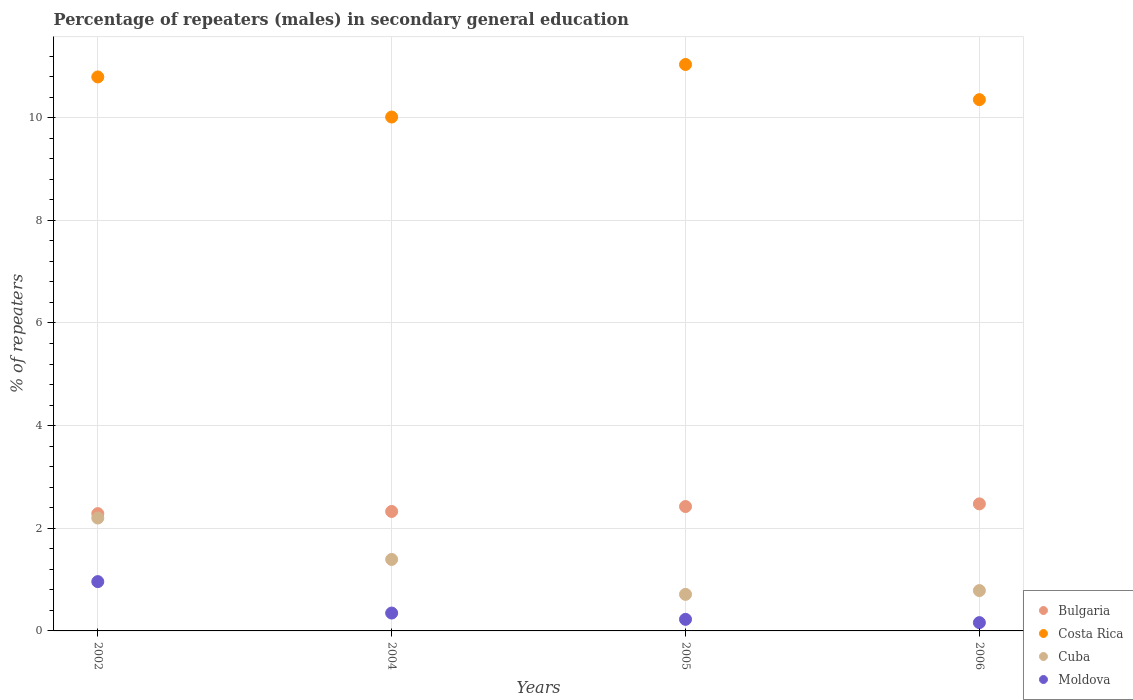What is the percentage of male repeaters in Costa Rica in 2004?
Offer a terse response. 10.01. Across all years, what is the maximum percentage of male repeaters in Bulgaria?
Make the answer very short. 2.48. Across all years, what is the minimum percentage of male repeaters in Costa Rica?
Ensure brevity in your answer.  10.01. What is the total percentage of male repeaters in Cuba in the graph?
Your answer should be compact. 5.09. What is the difference between the percentage of male repeaters in Moldova in 2002 and that in 2005?
Make the answer very short. 0.73. What is the difference between the percentage of male repeaters in Bulgaria in 2002 and the percentage of male repeaters in Moldova in 2005?
Your response must be concise. 2.06. What is the average percentage of male repeaters in Cuba per year?
Provide a succinct answer. 1.27. In the year 2002, what is the difference between the percentage of male repeaters in Bulgaria and percentage of male repeaters in Cuba?
Give a very brief answer. 0.09. In how many years, is the percentage of male repeaters in Bulgaria greater than 9.6 %?
Your answer should be very brief. 0. What is the ratio of the percentage of male repeaters in Moldova in 2005 to that in 2006?
Offer a very short reply. 1.4. Is the percentage of male repeaters in Bulgaria in 2002 less than that in 2004?
Make the answer very short. Yes. Is the difference between the percentage of male repeaters in Bulgaria in 2004 and 2006 greater than the difference between the percentage of male repeaters in Cuba in 2004 and 2006?
Give a very brief answer. No. What is the difference between the highest and the second highest percentage of male repeaters in Moldova?
Your answer should be very brief. 0.61. What is the difference between the highest and the lowest percentage of male repeaters in Costa Rica?
Your response must be concise. 1.02. In how many years, is the percentage of male repeaters in Cuba greater than the average percentage of male repeaters in Cuba taken over all years?
Provide a short and direct response. 2. Is the sum of the percentage of male repeaters in Cuba in 2002 and 2004 greater than the maximum percentage of male repeaters in Costa Rica across all years?
Keep it short and to the point. No. Is it the case that in every year, the sum of the percentage of male repeaters in Moldova and percentage of male repeaters in Bulgaria  is greater than the percentage of male repeaters in Cuba?
Provide a short and direct response. Yes. How many dotlines are there?
Offer a terse response. 4. How many years are there in the graph?
Your answer should be compact. 4. What is the difference between two consecutive major ticks on the Y-axis?
Your answer should be compact. 2. Are the values on the major ticks of Y-axis written in scientific E-notation?
Provide a short and direct response. No. Does the graph contain grids?
Offer a terse response. Yes. Where does the legend appear in the graph?
Provide a succinct answer. Bottom right. What is the title of the graph?
Ensure brevity in your answer.  Percentage of repeaters (males) in secondary general education. Does "Burundi" appear as one of the legend labels in the graph?
Keep it short and to the point. No. What is the label or title of the Y-axis?
Provide a succinct answer. % of repeaters. What is the % of repeaters in Bulgaria in 2002?
Make the answer very short. 2.29. What is the % of repeaters of Costa Rica in 2002?
Make the answer very short. 10.79. What is the % of repeaters of Cuba in 2002?
Your answer should be compact. 2.2. What is the % of repeaters in Moldova in 2002?
Your answer should be very brief. 0.96. What is the % of repeaters of Bulgaria in 2004?
Offer a terse response. 2.33. What is the % of repeaters in Costa Rica in 2004?
Your answer should be compact. 10.01. What is the % of repeaters of Cuba in 2004?
Give a very brief answer. 1.39. What is the % of repeaters of Moldova in 2004?
Give a very brief answer. 0.35. What is the % of repeaters of Bulgaria in 2005?
Offer a terse response. 2.42. What is the % of repeaters of Costa Rica in 2005?
Offer a very short reply. 11.04. What is the % of repeaters of Cuba in 2005?
Your answer should be very brief. 0.71. What is the % of repeaters of Moldova in 2005?
Provide a succinct answer. 0.23. What is the % of repeaters in Bulgaria in 2006?
Ensure brevity in your answer.  2.48. What is the % of repeaters of Costa Rica in 2006?
Give a very brief answer. 10.35. What is the % of repeaters in Cuba in 2006?
Ensure brevity in your answer.  0.79. What is the % of repeaters of Moldova in 2006?
Offer a very short reply. 0.16. Across all years, what is the maximum % of repeaters of Bulgaria?
Your answer should be compact. 2.48. Across all years, what is the maximum % of repeaters of Costa Rica?
Offer a terse response. 11.04. Across all years, what is the maximum % of repeaters in Cuba?
Provide a short and direct response. 2.2. Across all years, what is the maximum % of repeaters in Moldova?
Offer a very short reply. 0.96. Across all years, what is the minimum % of repeaters in Bulgaria?
Ensure brevity in your answer.  2.29. Across all years, what is the minimum % of repeaters in Costa Rica?
Give a very brief answer. 10.01. Across all years, what is the minimum % of repeaters of Cuba?
Offer a very short reply. 0.71. Across all years, what is the minimum % of repeaters in Moldova?
Provide a short and direct response. 0.16. What is the total % of repeaters in Bulgaria in the graph?
Your answer should be compact. 9.51. What is the total % of repeaters of Costa Rica in the graph?
Ensure brevity in your answer.  42.19. What is the total % of repeaters of Cuba in the graph?
Offer a terse response. 5.09. What is the total % of repeaters of Moldova in the graph?
Ensure brevity in your answer.  1.7. What is the difference between the % of repeaters in Bulgaria in 2002 and that in 2004?
Your response must be concise. -0.04. What is the difference between the % of repeaters of Costa Rica in 2002 and that in 2004?
Offer a very short reply. 0.78. What is the difference between the % of repeaters in Cuba in 2002 and that in 2004?
Offer a terse response. 0.81. What is the difference between the % of repeaters in Moldova in 2002 and that in 2004?
Your answer should be compact. 0.61. What is the difference between the % of repeaters of Bulgaria in 2002 and that in 2005?
Ensure brevity in your answer.  -0.14. What is the difference between the % of repeaters of Costa Rica in 2002 and that in 2005?
Provide a succinct answer. -0.24. What is the difference between the % of repeaters of Cuba in 2002 and that in 2005?
Offer a terse response. 1.49. What is the difference between the % of repeaters in Moldova in 2002 and that in 2005?
Offer a very short reply. 0.73. What is the difference between the % of repeaters in Bulgaria in 2002 and that in 2006?
Offer a terse response. -0.19. What is the difference between the % of repeaters in Costa Rica in 2002 and that in 2006?
Keep it short and to the point. 0.44. What is the difference between the % of repeaters in Cuba in 2002 and that in 2006?
Give a very brief answer. 1.41. What is the difference between the % of repeaters of Moldova in 2002 and that in 2006?
Your response must be concise. 0.8. What is the difference between the % of repeaters of Bulgaria in 2004 and that in 2005?
Give a very brief answer. -0.1. What is the difference between the % of repeaters in Costa Rica in 2004 and that in 2005?
Provide a short and direct response. -1.02. What is the difference between the % of repeaters of Cuba in 2004 and that in 2005?
Keep it short and to the point. 0.68. What is the difference between the % of repeaters in Moldova in 2004 and that in 2005?
Make the answer very short. 0.12. What is the difference between the % of repeaters of Bulgaria in 2004 and that in 2006?
Your answer should be compact. -0.15. What is the difference between the % of repeaters in Costa Rica in 2004 and that in 2006?
Your response must be concise. -0.34. What is the difference between the % of repeaters of Cuba in 2004 and that in 2006?
Your answer should be compact. 0.61. What is the difference between the % of repeaters in Moldova in 2004 and that in 2006?
Make the answer very short. 0.19. What is the difference between the % of repeaters in Bulgaria in 2005 and that in 2006?
Offer a very short reply. -0.05. What is the difference between the % of repeaters in Costa Rica in 2005 and that in 2006?
Make the answer very short. 0.69. What is the difference between the % of repeaters of Cuba in 2005 and that in 2006?
Your answer should be compact. -0.07. What is the difference between the % of repeaters of Moldova in 2005 and that in 2006?
Your answer should be very brief. 0.06. What is the difference between the % of repeaters of Bulgaria in 2002 and the % of repeaters of Costa Rica in 2004?
Offer a terse response. -7.73. What is the difference between the % of repeaters in Bulgaria in 2002 and the % of repeaters in Cuba in 2004?
Offer a very short reply. 0.89. What is the difference between the % of repeaters of Bulgaria in 2002 and the % of repeaters of Moldova in 2004?
Offer a very short reply. 1.94. What is the difference between the % of repeaters of Costa Rica in 2002 and the % of repeaters of Cuba in 2004?
Provide a short and direct response. 9.4. What is the difference between the % of repeaters in Costa Rica in 2002 and the % of repeaters in Moldova in 2004?
Your answer should be compact. 10.45. What is the difference between the % of repeaters of Cuba in 2002 and the % of repeaters of Moldova in 2004?
Offer a terse response. 1.85. What is the difference between the % of repeaters in Bulgaria in 2002 and the % of repeaters in Costa Rica in 2005?
Your response must be concise. -8.75. What is the difference between the % of repeaters of Bulgaria in 2002 and the % of repeaters of Cuba in 2005?
Keep it short and to the point. 1.57. What is the difference between the % of repeaters in Bulgaria in 2002 and the % of repeaters in Moldova in 2005?
Ensure brevity in your answer.  2.06. What is the difference between the % of repeaters in Costa Rica in 2002 and the % of repeaters in Cuba in 2005?
Your response must be concise. 10.08. What is the difference between the % of repeaters in Costa Rica in 2002 and the % of repeaters in Moldova in 2005?
Your answer should be very brief. 10.57. What is the difference between the % of repeaters of Cuba in 2002 and the % of repeaters of Moldova in 2005?
Give a very brief answer. 1.97. What is the difference between the % of repeaters of Bulgaria in 2002 and the % of repeaters of Costa Rica in 2006?
Offer a terse response. -8.07. What is the difference between the % of repeaters in Bulgaria in 2002 and the % of repeaters in Cuba in 2006?
Provide a succinct answer. 1.5. What is the difference between the % of repeaters of Bulgaria in 2002 and the % of repeaters of Moldova in 2006?
Provide a succinct answer. 2.12. What is the difference between the % of repeaters of Costa Rica in 2002 and the % of repeaters of Cuba in 2006?
Offer a very short reply. 10.01. What is the difference between the % of repeaters of Costa Rica in 2002 and the % of repeaters of Moldova in 2006?
Provide a succinct answer. 10.63. What is the difference between the % of repeaters of Cuba in 2002 and the % of repeaters of Moldova in 2006?
Your response must be concise. 2.04. What is the difference between the % of repeaters of Bulgaria in 2004 and the % of repeaters of Costa Rica in 2005?
Give a very brief answer. -8.71. What is the difference between the % of repeaters of Bulgaria in 2004 and the % of repeaters of Cuba in 2005?
Your answer should be compact. 1.62. What is the difference between the % of repeaters in Bulgaria in 2004 and the % of repeaters in Moldova in 2005?
Offer a very short reply. 2.1. What is the difference between the % of repeaters in Costa Rica in 2004 and the % of repeaters in Cuba in 2005?
Ensure brevity in your answer.  9.3. What is the difference between the % of repeaters in Costa Rica in 2004 and the % of repeaters in Moldova in 2005?
Offer a very short reply. 9.79. What is the difference between the % of repeaters of Cuba in 2004 and the % of repeaters of Moldova in 2005?
Keep it short and to the point. 1.17. What is the difference between the % of repeaters in Bulgaria in 2004 and the % of repeaters in Costa Rica in 2006?
Provide a short and direct response. -8.02. What is the difference between the % of repeaters in Bulgaria in 2004 and the % of repeaters in Cuba in 2006?
Your response must be concise. 1.54. What is the difference between the % of repeaters of Bulgaria in 2004 and the % of repeaters of Moldova in 2006?
Your answer should be very brief. 2.17. What is the difference between the % of repeaters of Costa Rica in 2004 and the % of repeaters of Cuba in 2006?
Your answer should be very brief. 9.23. What is the difference between the % of repeaters in Costa Rica in 2004 and the % of repeaters in Moldova in 2006?
Provide a short and direct response. 9.85. What is the difference between the % of repeaters of Cuba in 2004 and the % of repeaters of Moldova in 2006?
Provide a short and direct response. 1.23. What is the difference between the % of repeaters of Bulgaria in 2005 and the % of repeaters of Costa Rica in 2006?
Offer a very short reply. -7.93. What is the difference between the % of repeaters in Bulgaria in 2005 and the % of repeaters in Cuba in 2006?
Offer a terse response. 1.64. What is the difference between the % of repeaters of Bulgaria in 2005 and the % of repeaters of Moldova in 2006?
Your answer should be compact. 2.26. What is the difference between the % of repeaters in Costa Rica in 2005 and the % of repeaters in Cuba in 2006?
Your answer should be compact. 10.25. What is the difference between the % of repeaters in Costa Rica in 2005 and the % of repeaters in Moldova in 2006?
Provide a succinct answer. 10.87. What is the difference between the % of repeaters in Cuba in 2005 and the % of repeaters in Moldova in 2006?
Your answer should be very brief. 0.55. What is the average % of repeaters of Bulgaria per year?
Your answer should be compact. 2.38. What is the average % of repeaters in Costa Rica per year?
Offer a very short reply. 10.55. What is the average % of repeaters of Cuba per year?
Give a very brief answer. 1.27. What is the average % of repeaters in Moldova per year?
Provide a short and direct response. 0.42. In the year 2002, what is the difference between the % of repeaters in Bulgaria and % of repeaters in Costa Rica?
Make the answer very short. -8.51. In the year 2002, what is the difference between the % of repeaters in Bulgaria and % of repeaters in Cuba?
Offer a very short reply. 0.09. In the year 2002, what is the difference between the % of repeaters in Bulgaria and % of repeaters in Moldova?
Ensure brevity in your answer.  1.32. In the year 2002, what is the difference between the % of repeaters of Costa Rica and % of repeaters of Cuba?
Your response must be concise. 8.59. In the year 2002, what is the difference between the % of repeaters in Costa Rica and % of repeaters in Moldova?
Your response must be concise. 9.83. In the year 2002, what is the difference between the % of repeaters in Cuba and % of repeaters in Moldova?
Ensure brevity in your answer.  1.24. In the year 2004, what is the difference between the % of repeaters of Bulgaria and % of repeaters of Costa Rica?
Keep it short and to the point. -7.69. In the year 2004, what is the difference between the % of repeaters in Bulgaria and % of repeaters in Cuba?
Your answer should be very brief. 0.93. In the year 2004, what is the difference between the % of repeaters in Bulgaria and % of repeaters in Moldova?
Keep it short and to the point. 1.98. In the year 2004, what is the difference between the % of repeaters of Costa Rica and % of repeaters of Cuba?
Keep it short and to the point. 8.62. In the year 2004, what is the difference between the % of repeaters of Costa Rica and % of repeaters of Moldova?
Your answer should be very brief. 9.66. In the year 2004, what is the difference between the % of repeaters of Cuba and % of repeaters of Moldova?
Your response must be concise. 1.04. In the year 2005, what is the difference between the % of repeaters of Bulgaria and % of repeaters of Costa Rica?
Provide a short and direct response. -8.61. In the year 2005, what is the difference between the % of repeaters of Bulgaria and % of repeaters of Cuba?
Offer a very short reply. 1.71. In the year 2005, what is the difference between the % of repeaters in Bulgaria and % of repeaters in Moldova?
Ensure brevity in your answer.  2.2. In the year 2005, what is the difference between the % of repeaters in Costa Rica and % of repeaters in Cuba?
Offer a terse response. 10.32. In the year 2005, what is the difference between the % of repeaters of Costa Rica and % of repeaters of Moldova?
Make the answer very short. 10.81. In the year 2005, what is the difference between the % of repeaters of Cuba and % of repeaters of Moldova?
Give a very brief answer. 0.49. In the year 2006, what is the difference between the % of repeaters in Bulgaria and % of repeaters in Costa Rica?
Your response must be concise. -7.88. In the year 2006, what is the difference between the % of repeaters in Bulgaria and % of repeaters in Cuba?
Provide a succinct answer. 1.69. In the year 2006, what is the difference between the % of repeaters in Bulgaria and % of repeaters in Moldova?
Offer a very short reply. 2.31. In the year 2006, what is the difference between the % of repeaters of Costa Rica and % of repeaters of Cuba?
Offer a terse response. 9.57. In the year 2006, what is the difference between the % of repeaters in Costa Rica and % of repeaters in Moldova?
Provide a short and direct response. 10.19. In the year 2006, what is the difference between the % of repeaters in Cuba and % of repeaters in Moldova?
Keep it short and to the point. 0.62. What is the ratio of the % of repeaters of Bulgaria in 2002 to that in 2004?
Provide a succinct answer. 0.98. What is the ratio of the % of repeaters in Costa Rica in 2002 to that in 2004?
Provide a short and direct response. 1.08. What is the ratio of the % of repeaters in Cuba in 2002 to that in 2004?
Provide a succinct answer. 1.58. What is the ratio of the % of repeaters in Moldova in 2002 to that in 2004?
Provide a short and direct response. 2.76. What is the ratio of the % of repeaters in Bulgaria in 2002 to that in 2005?
Keep it short and to the point. 0.94. What is the ratio of the % of repeaters in Cuba in 2002 to that in 2005?
Your response must be concise. 3.09. What is the ratio of the % of repeaters in Moldova in 2002 to that in 2005?
Keep it short and to the point. 4.26. What is the ratio of the % of repeaters of Bulgaria in 2002 to that in 2006?
Give a very brief answer. 0.92. What is the ratio of the % of repeaters in Costa Rica in 2002 to that in 2006?
Your response must be concise. 1.04. What is the ratio of the % of repeaters of Cuba in 2002 to that in 2006?
Keep it short and to the point. 2.8. What is the ratio of the % of repeaters of Moldova in 2002 to that in 2006?
Keep it short and to the point. 5.94. What is the ratio of the % of repeaters in Bulgaria in 2004 to that in 2005?
Provide a short and direct response. 0.96. What is the ratio of the % of repeaters of Costa Rica in 2004 to that in 2005?
Your answer should be compact. 0.91. What is the ratio of the % of repeaters of Cuba in 2004 to that in 2005?
Make the answer very short. 1.96. What is the ratio of the % of repeaters in Moldova in 2004 to that in 2005?
Ensure brevity in your answer.  1.54. What is the ratio of the % of repeaters in Bulgaria in 2004 to that in 2006?
Provide a succinct answer. 0.94. What is the ratio of the % of repeaters in Costa Rica in 2004 to that in 2006?
Your response must be concise. 0.97. What is the ratio of the % of repeaters in Cuba in 2004 to that in 2006?
Your answer should be very brief. 1.77. What is the ratio of the % of repeaters in Moldova in 2004 to that in 2006?
Ensure brevity in your answer.  2.15. What is the ratio of the % of repeaters in Bulgaria in 2005 to that in 2006?
Provide a short and direct response. 0.98. What is the ratio of the % of repeaters in Costa Rica in 2005 to that in 2006?
Provide a succinct answer. 1.07. What is the ratio of the % of repeaters of Cuba in 2005 to that in 2006?
Ensure brevity in your answer.  0.91. What is the ratio of the % of repeaters of Moldova in 2005 to that in 2006?
Provide a short and direct response. 1.4. What is the difference between the highest and the second highest % of repeaters in Bulgaria?
Offer a terse response. 0.05. What is the difference between the highest and the second highest % of repeaters of Costa Rica?
Ensure brevity in your answer.  0.24. What is the difference between the highest and the second highest % of repeaters of Cuba?
Ensure brevity in your answer.  0.81. What is the difference between the highest and the second highest % of repeaters of Moldova?
Ensure brevity in your answer.  0.61. What is the difference between the highest and the lowest % of repeaters of Bulgaria?
Give a very brief answer. 0.19. What is the difference between the highest and the lowest % of repeaters in Costa Rica?
Provide a short and direct response. 1.02. What is the difference between the highest and the lowest % of repeaters of Cuba?
Your response must be concise. 1.49. What is the difference between the highest and the lowest % of repeaters in Moldova?
Make the answer very short. 0.8. 